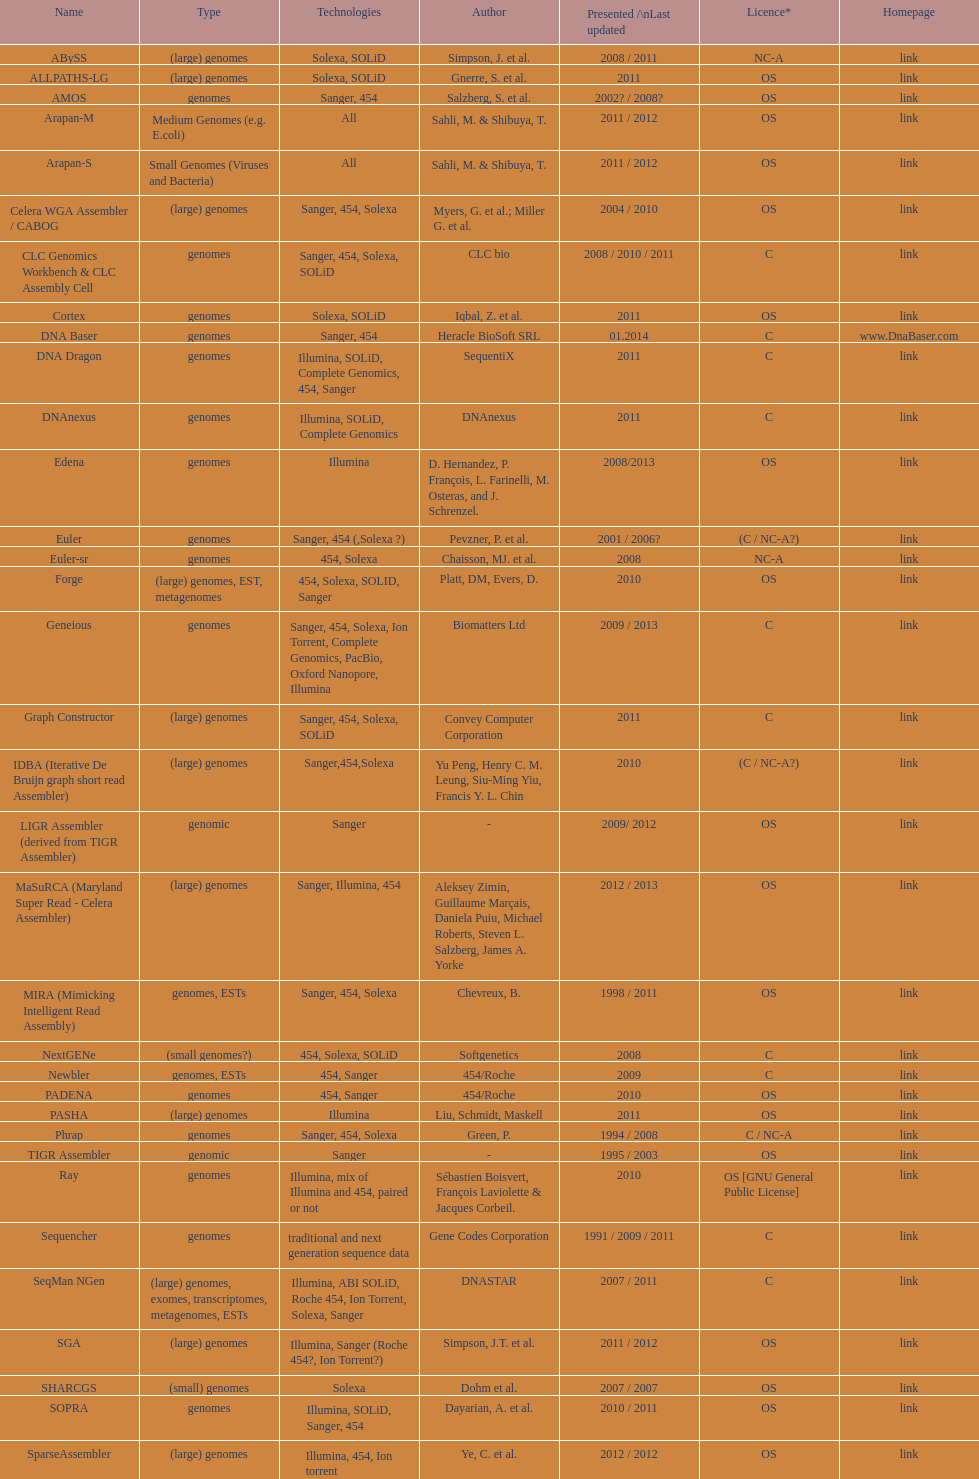What is the count of "all" technologies listed? 2. 